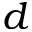Convert formula to latex. <formula><loc_0><loc_0><loc_500><loc_500>d</formula> 